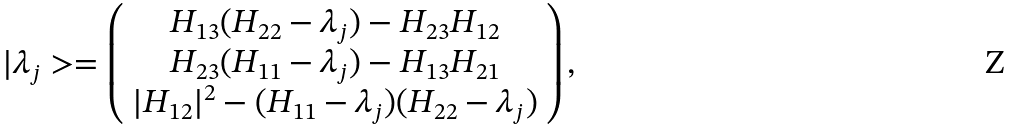Convert formula to latex. <formula><loc_0><loc_0><loc_500><loc_500>| \lambda _ { j } > = \left ( \begin{array} { c } { { H _ { 1 3 } ( H _ { 2 2 } - \lambda _ { j } ) - H _ { 2 3 } H _ { 1 2 } } } \\ { { H _ { 2 3 } ( H _ { 1 1 } - \lambda _ { j } ) - H _ { 1 3 } H _ { 2 1 } } } \\ { { | H _ { 1 2 } | ^ { 2 } - ( H _ { 1 1 } - \lambda _ { j } ) ( H _ { 2 2 } - \lambda _ { j } ) } } \end{array} \right ) ,</formula> 